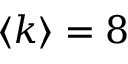Convert formula to latex. <formula><loc_0><loc_0><loc_500><loc_500>\langle k \rangle = 8</formula> 